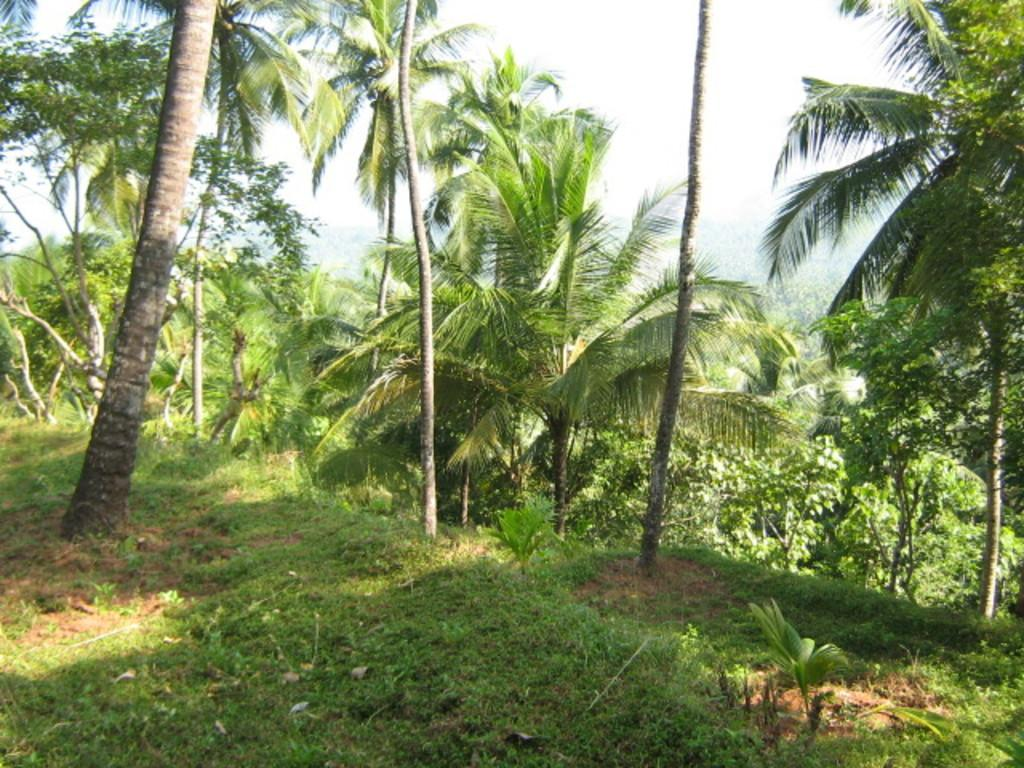What is the main feature in the center of the image? There are trees in the center of the image. What type of vegetation is present at the bottom of the image? There is grass and plants at the bottom of the image. What can be seen at the top of the image? The sky is visible at the top of the image. What type of mint is growing in the image? There is no mint present in the image. Where is the vacation destination in the image? The image does not depict a vacation destination; it features trees, grass, plants, and the sky. 